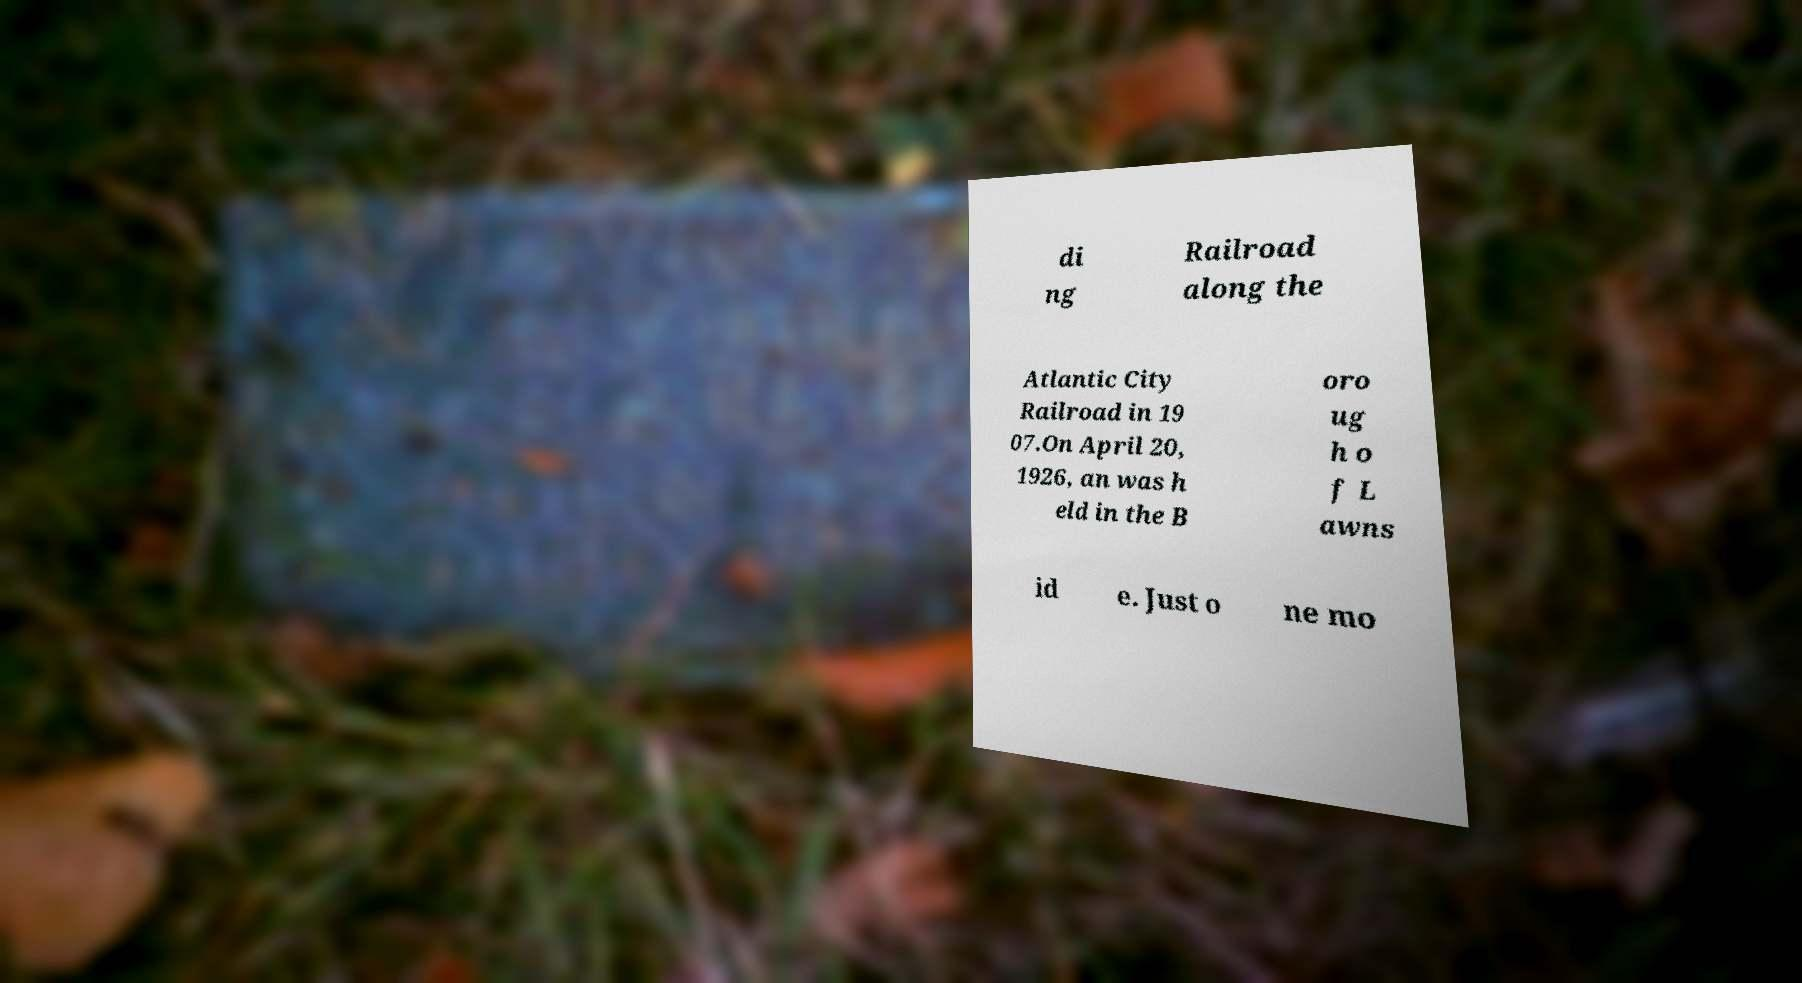There's text embedded in this image that I need extracted. Can you transcribe it verbatim? di ng Railroad along the Atlantic City Railroad in 19 07.On April 20, 1926, an was h eld in the B oro ug h o f L awns id e. Just o ne mo 